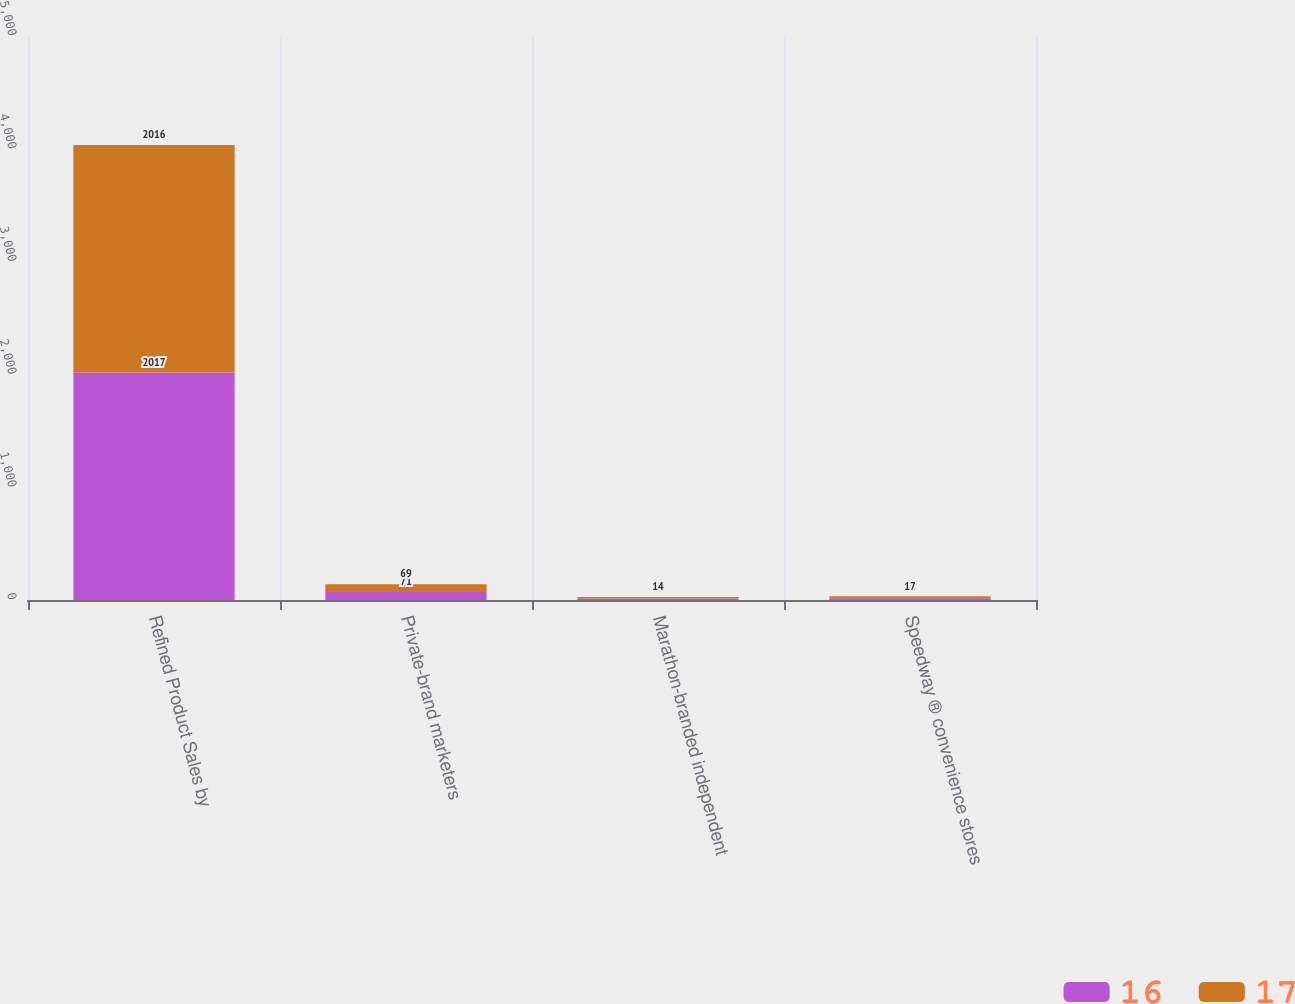<chart> <loc_0><loc_0><loc_500><loc_500><stacked_bar_chart><ecel><fcel>Refined Product Sales by<fcel>Private-brand marketers<fcel>Marathon-branded independent<fcel>Speedway ® convenience stores<nl><fcel>16<fcel>2017<fcel>71<fcel>13<fcel>16<nl><fcel>17<fcel>2016<fcel>69<fcel>14<fcel>17<nl></chart> 